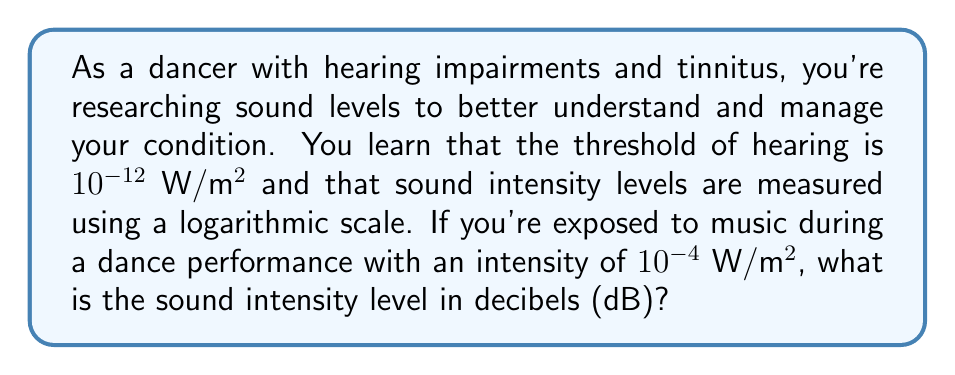Help me with this question. Let's approach this step-by-step:

1) The formula for sound intensity level (SIL) in decibels is:

   $$ SIL = 10 \log_{10}\left(\frac{I}{I_0}\right) \text{ dB} $$

   Where:
   $I$ is the intensity of the sound in W/m²
   $I_0$ is the reference intensity (threshold of hearing) = $10^{-12}$ W/m²

2) We're given:
   $I = 10^{-4}$ W/m²
   $I_0 = 10^{-12}$ W/m²

3) Let's substitute these values into the formula:

   $$ SIL = 10 \log_{10}\left(\frac{10^{-4}}{10^{-12}}\right) \text{ dB} $$

4) Simplify inside the parentheses:

   $$ SIL = 10 \log_{10}(10^8) \text{ dB} $$

5) Use the logarithm property $\log_a(x^n) = n\log_a(x)$:

   $$ SIL = 10 \cdot 8 \log_{10}(10) \text{ dB} $$

6) $\log_{10}(10) = 1$, so:

   $$ SIL = 10 \cdot 8 \text{ dB} = 80 \text{ dB} $$
Answer: 80 dB 